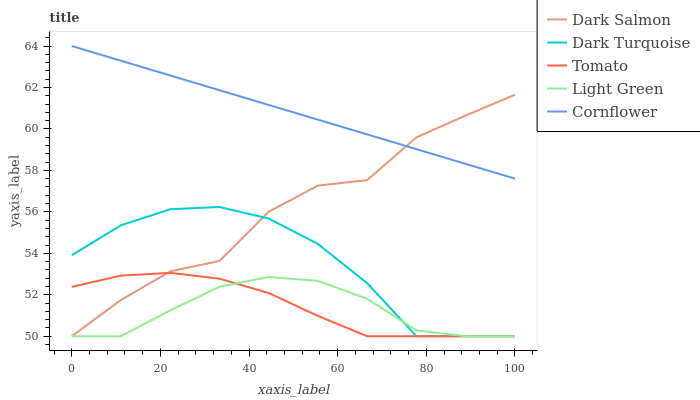Does Light Green have the minimum area under the curve?
Answer yes or no. Yes. Does Cornflower have the maximum area under the curve?
Answer yes or no. Yes. Does Dark Turquoise have the minimum area under the curve?
Answer yes or no. No. Does Dark Turquoise have the maximum area under the curve?
Answer yes or no. No. Is Cornflower the smoothest?
Answer yes or no. Yes. Is Dark Salmon the roughest?
Answer yes or no. Yes. Is Dark Turquoise the smoothest?
Answer yes or no. No. Is Dark Turquoise the roughest?
Answer yes or no. No. Does Tomato have the lowest value?
Answer yes or no. Yes. Does Cornflower have the lowest value?
Answer yes or no. No. Does Cornflower have the highest value?
Answer yes or no. Yes. Does Dark Turquoise have the highest value?
Answer yes or no. No. Is Light Green less than Cornflower?
Answer yes or no. Yes. Is Cornflower greater than Tomato?
Answer yes or no. Yes. Does Cornflower intersect Dark Salmon?
Answer yes or no. Yes. Is Cornflower less than Dark Salmon?
Answer yes or no. No. Is Cornflower greater than Dark Salmon?
Answer yes or no. No. Does Light Green intersect Cornflower?
Answer yes or no. No. 